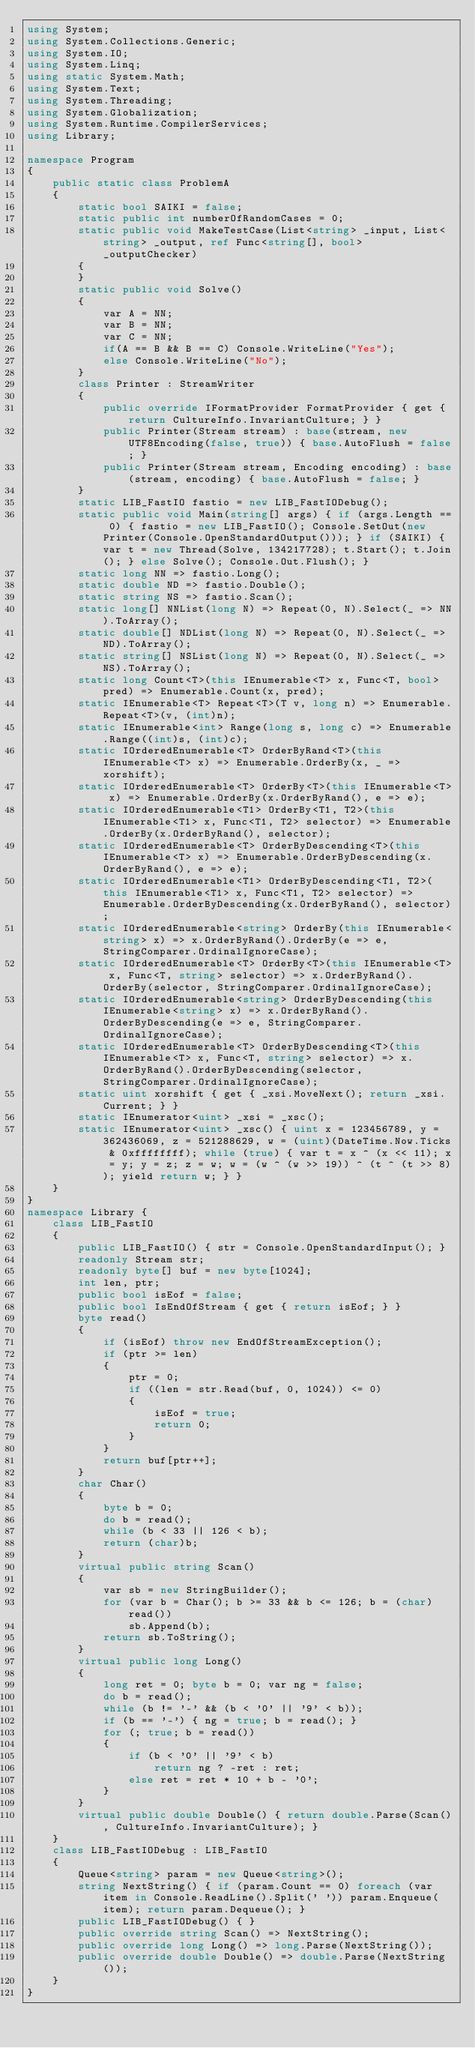Convert code to text. <code><loc_0><loc_0><loc_500><loc_500><_C#_>using System;
using System.Collections.Generic;
using System.IO;
using System.Linq;
using static System.Math;
using System.Text;
using System.Threading;
using System.Globalization;
using System.Runtime.CompilerServices;
using Library;

namespace Program
{
    public static class ProblemA
    {
        static bool SAIKI = false;
        static public int numberOfRandomCases = 0;
        static public void MakeTestCase(List<string> _input, List<string> _output, ref Func<string[], bool> _outputChecker)
        {
        }
        static public void Solve()
        {
            var A = NN;
            var B = NN;
            var C = NN;
            if(A == B && B == C) Console.WriteLine("Yes");
            else Console.WriteLine("No");
        }
        class Printer : StreamWriter
        {
            public override IFormatProvider FormatProvider { get { return CultureInfo.InvariantCulture; } }
            public Printer(Stream stream) : base(stream, new UTF8Encoding(false, true)) { base.AutoFlush = false; }
            public Printer(Stream stream, Encoding encoding) : base(stream, encoding) { base.AutoFlush = false; }
        }
        static LIB_FastIO fastio = new LIB_FastIODebug();
        static public void Main(string[] args) { if (args.Length == 0) { fastio = new LIB_FastIO(); Console.SetOut(new Printer(Console.OpenStandardOutput())); } if (SAIKI) { var t = new Thread(Solve, 134217728); t.Start(); t.Join(); } else Solve(); Console.Out.Flush(); }
        static long NN => fastio.Long();
        static double ND => fastio.Double();
        static string NS => fastio.Scan();
        static long[] NNList(long N) => Repeat(0, N).Select(_ => NN).ToArray();
        static double[] NDList(long N) => Repeat(0, N).Select(_ => ND).ToArray();
        static string[] NSList(long N) => Repeat(0, N).Select(_ => NS).ToArray();
        static long Count<T>(this IEnumerable<T> x, Func<T, bool> pred) => Enumerable.Count(x, pred);
        static IEnumerable<T> Repeat<T>(T v, long n) => Enumerable.Repeat<T>(v, (int)n);
        static IEnumerable<int> Range(long s, long c) => Enumerable.Range((int)s, (int)c);
        static IOrderedEnumerable<T> OrderByRand<T>(this IEnumerable<T> x) => Enumerable.OrderBy(x, _ => xorshift);
        static IOrderedEnumerable<T> OrderBy<T>(this IEnumerable<T> x) => Enumerable.OrderBy(x.OrderByRand(), e => e);
        static IOrderedEnumerable<T1> OrderBy<T1, T2>(this IEnumerable<T1> x, Func<T1, T2> selector) => Enumerable.OrderBy(x.OrderByRand(), selector);
        static IOrderedEnumerable<T> OrderByDescending<T>(this IEnumerable<T> x) => Enumerable.OrderByDescending(x.OrderByRand(), e => e);
        static IOrderedEnumerable<T1> OrderByDescending<T1, T2>(this IEnumerable<T1> x, Func<T1, T2> selector) => Enumerable.OrderByDescending(x.OrderByRand(), selector);
        static IOrderedEnumerable<string> OrderBy(this IEnumerable<string> x) => x.OrderByRand().OrderBy(e => e, StringComparer.OrdinalIgnoreCase);
        static IOrderedEnumerable<T> OrderBy<T>(this IEnumerable<T> x, Func<T, string> selector) => x.OrderByRand().OrderBy(selector, StringComparer.OrdinalIgnoreCase);
        static IOrderedEnumerable<string> OrderByDescending(this IEnumerable<string> x) => x.OrderByRand().OrderByDescending(e => e, StringComparer.OrdinalIgnoreCase);
        static IOrderedEnumerable<T> OrderByDescending<T>(this IEnumerable<T> x, Func<T, string> selector) => x.OrderByRand().OrderByDescending(selector, StringComparer.OrdinalIgnoreCase);
        static uint xorshift { get { _xsi.MoveNext(); return _xsi.Current; } }
        static IEnumerator<uint> _xsi = _xsc();
        static IEnumerator<uint> _xsc() { uint x = 123456789, y = 362436069, z = 521288629, w = (uint)(DateTime.Now.Ticks & 0xffffffff); while (true) { var t = x ^ (x << 11); x = y; y = z; z = w; w = (w ^ (w >> 19)) ^ (t ^ (t >> 8)); yield return w; } }
    }
}
namespace Library {
    class LIB_FastIO
    {
        public LIB_FastIO() { str = Console.OpenStandardInput(); }
        readonly Stream str;
        readonly byte[] buf = new byte[1024];
        int len, ptr;
        public bool isEof = false;
        public bool IsEndOfStream { get { return isEof; } }
        byte read()
        {
            if (isEof) throw new EndOfStreamException();
            if (ptr >= len)
            {
                ptr = 0;
                if ((len = str.Read(buf, 0, 1024)) <= 0)
                {
                    isEof = true;
                    return 0;
                }
            }
            return buf[ptr++];
        }
        char Char()
        {
            byte b = 0;
            do b = read();
            while (b < 33 || 126 < b);
            return (char)b;
        }
        virtual public string Scan()
        {
            var sb = new StringBuilder();
            for (var b = Char(); b >= 33 && b <= 126; b = (char)read())
                sb.Append(b);
            return sb.ToString();
        }
        virtual public long Long()
        {
            long ret = 0; byte b = 0; var ng = false;
            do b = read();
            while (b != '-' && (b < '0' || '9' < b));
            if (b == '-') { ng = true; b = read(); }
            for (; true; b = read())
            {
                if (b < '0' || '9' < b)
                    return ng ? -ret : ret;
                else ret = ret * 10 + b - '0';
            }
        }
        virtual public double Double() { return double.Parse(Scan(), CultureInfo.InvariantCulture); }
    }
    class LIB_FastIODebug : LIB_FastIO
    {
        Queue<string> param = new Queue<string>();
        string NextString() { if (param.Count == 0) foreach (var item in Console.ReadLine().Split(' ')) param.Enqueue(item); return param.Dequeue(); }
        public LIB_FastIODebug() { }
        public override string Scan() => NextString();
        public override long Long() => long.Parse(NextString());
        public override double Double() => double.Parse(NextString());
    }
}
</code> 